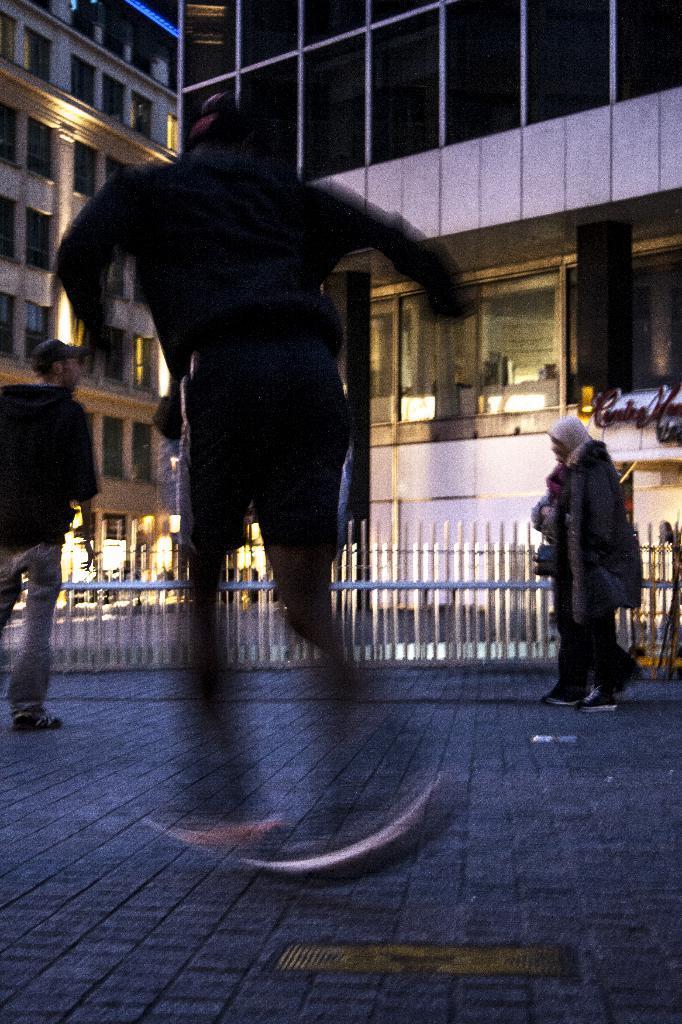How would you summarize this image in a sentence or two? In this image I can see few people. Back I can see few buildings,windows and fencing. 